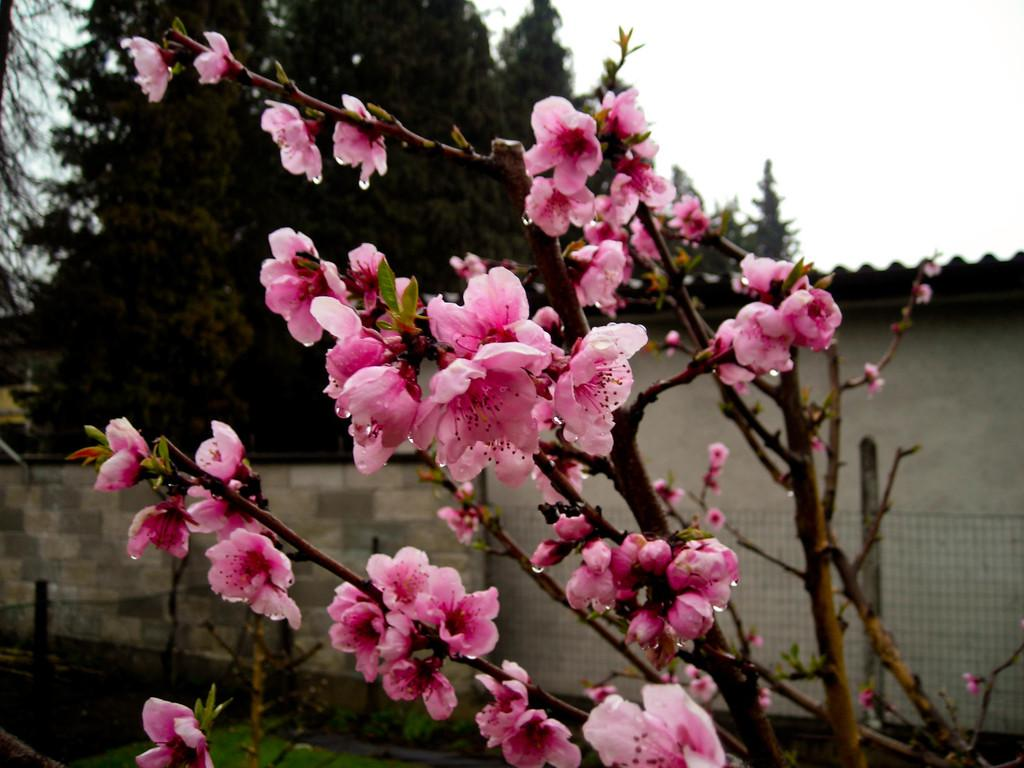What type of vegetation can be seen in the image? There are trees and flowers in the image. What is the color of the flowers in the image? The flowers in the image are pink in color. What structures are present in the image? There is a wall and a shed in the image. What part of the natural environment is visible in the image? The sky is visible in the background of the image. What type of trousers are hanging on the wall in the image? There are no trousers present in the image; it features trees, flowers, a wall, and a shed. What type of art can be seen on the flowers in the image? There is no art present on the flowers in the image; they are simply pink flowers. 